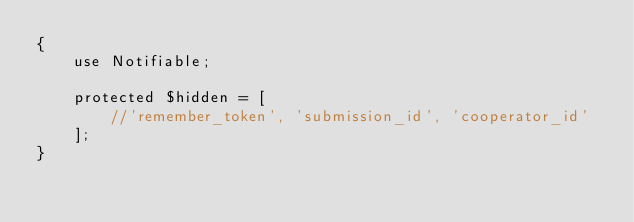<code> <loc_0><loc_0><loc_500><loc_500><_PHP_>{
    use Notifiable;

    protected $hidden = [
        //'remember_token', 'submission_id', 'cooperator_id'
    ];
}
</code> 